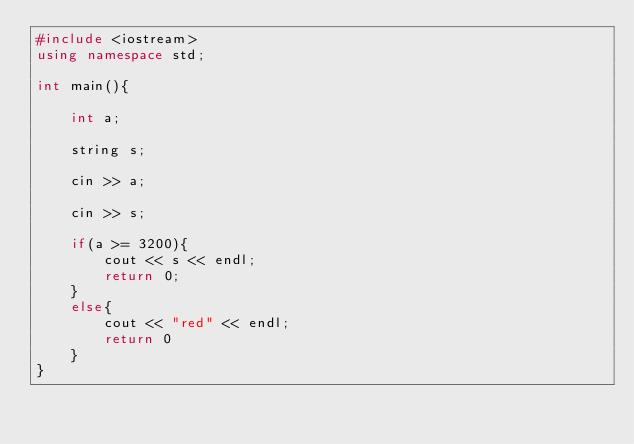<code> <loc_0><loc_0><loc_500><loc_500><_C++_>#include <iostream>
using namespace std;
 
int main(){

    int a;

    string s;

	cin >> a;

    cin >> s;

    if(a >= 3200){
        cout << s << endl;
        return 0;
    }
    else{
        cout << "red" << endl;
        return 0
    }
}</code> 